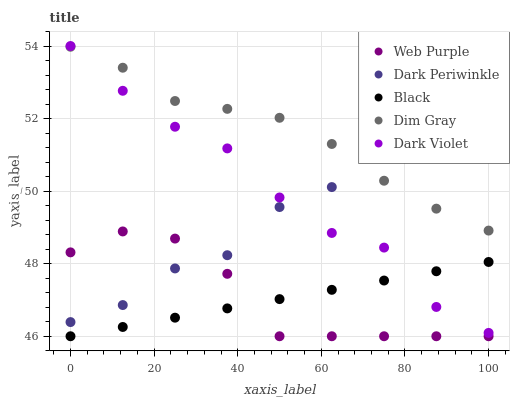Does Black have the minimum area under the curve?
Answer yes or no. Yes. Does Dim Gray have the maximum area under the curve?
Answer yes or no. Yes. Does Dim Gray have the minimum area under the curve?
Answer yes or no. No. Does Black have the maximum area under the curve?
Answer yes or no. No. Is Black the smoothest?
Answer yes or no. Yes. Is Dark Violet the roughest?
Answer yes or no. Yes. Is Dim Gray the smoothest?
Answer yes or no. No. Is Dim Gray the roughest?
Answer yes or no. No. Does Web Purple have the lowest value?
Answer yes or no. Yes. Does Dim Gray have the lowest value?
Answer yes or no. No. Does Dark Violet have the highest value?
Answer yes or no. Yes. Does Dim Gray have the highest value?
Answer yes or no. No. Is Web Purple less than Dim Gray?
Answer yes or no. Yes. Is Dark Violet greater than Web Purple?
Answer yes or no. Yes. Does Dark Periwinkle intersect Dark Violet?
Answer yes or no. Yes. Is Dark Periwinkle less than Dark Violet?
Answer yes or no. No. Is Dark Periwinkle greater than Dark Violet?
Answer yes or no. No. Does Web Purple intersect Dim Gray?
Answer yes or no. No. 